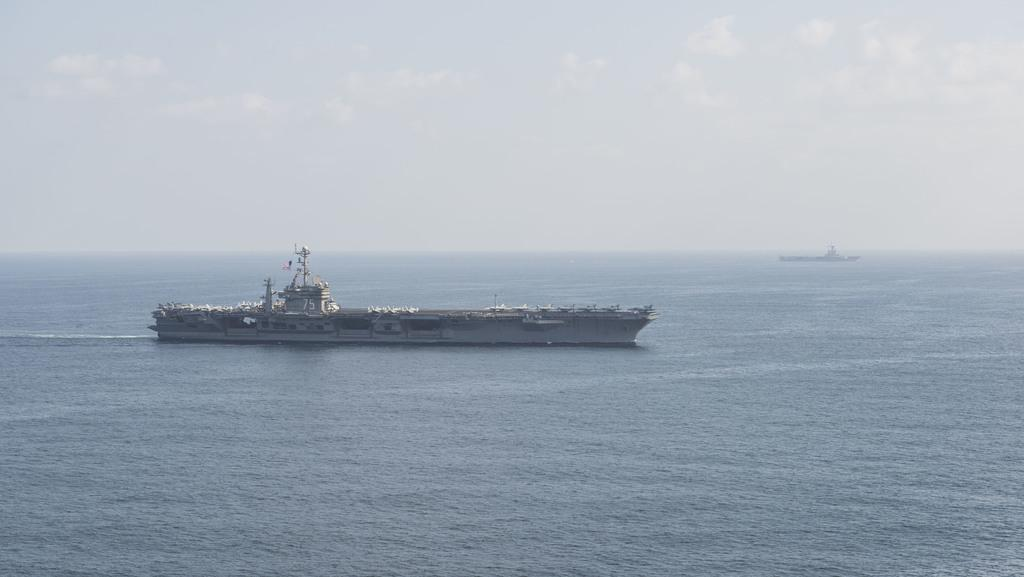What can be seen in the image related to transportation? There are two ships in the image. Where are the ships located? The ships are in a large water body. What else is visible in the image besides the ships? The sky is visible in the image. How would you describe the weather based on the sky? The sky appears cloudy. What type of hook can be seen hanging from the ship in the image? There is no hook visible in the image; only the ships and the sky are present. 